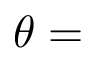Convert formula to latex. <formula><loc_0><loc_0><loc_500><loc_500>\theta =</formula> 